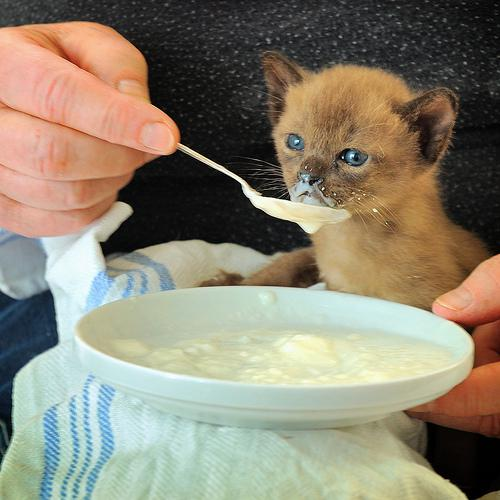Question: what is in the person's lap?
Choices:
A. A baby girl.
B. Her handbag.
C. Baby cat.
D. Shopping bags.
Answer with the letter. Answer: C Question: where is the cat sitting?
Choices:
A. On a window sill.
B. In a person's lap.
C. In the chair.
D. On the coffee table.
Answer with the letter. Answer: B Question: what color are the cat's eyes?
Choices:
A. Green.
B. Yellow.
C. Blue.
D. Brown.
Answer with the letter. Answer: C Question: why is the cat being spoon-fed?
Choices:
A. Too young to eat on his own.
B. Hurt mouth.
C. Mother left.
D. Sick.
Answer with the letter. Answer: A 